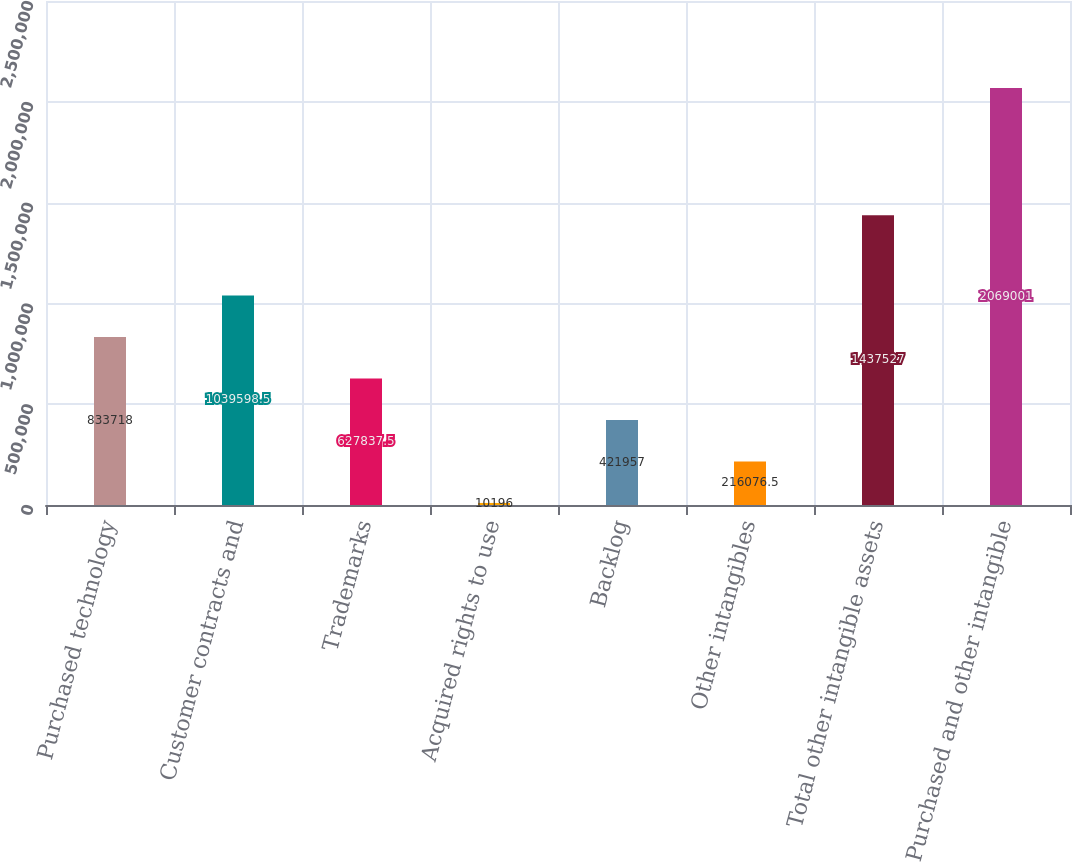<chart> <loc_0><loc_0><loc_500><loc_500><bar_chart><fcel>Purchased technology<fcel>Customer contracts and<fcel>Trademarks<fcel>Acquired rights to use<fcel>Backlog<fcel>Other intangibles<fcel>Total other intangible assets<fcel>Purchased and other intangible<nl><fcel>833718<fcel>1.0396e+06<fcel>627838<fcel>10196<fcel>421957<fcel>216076<fcel>1.43753e+06<fcel>2.069e+06<nl></chart> 